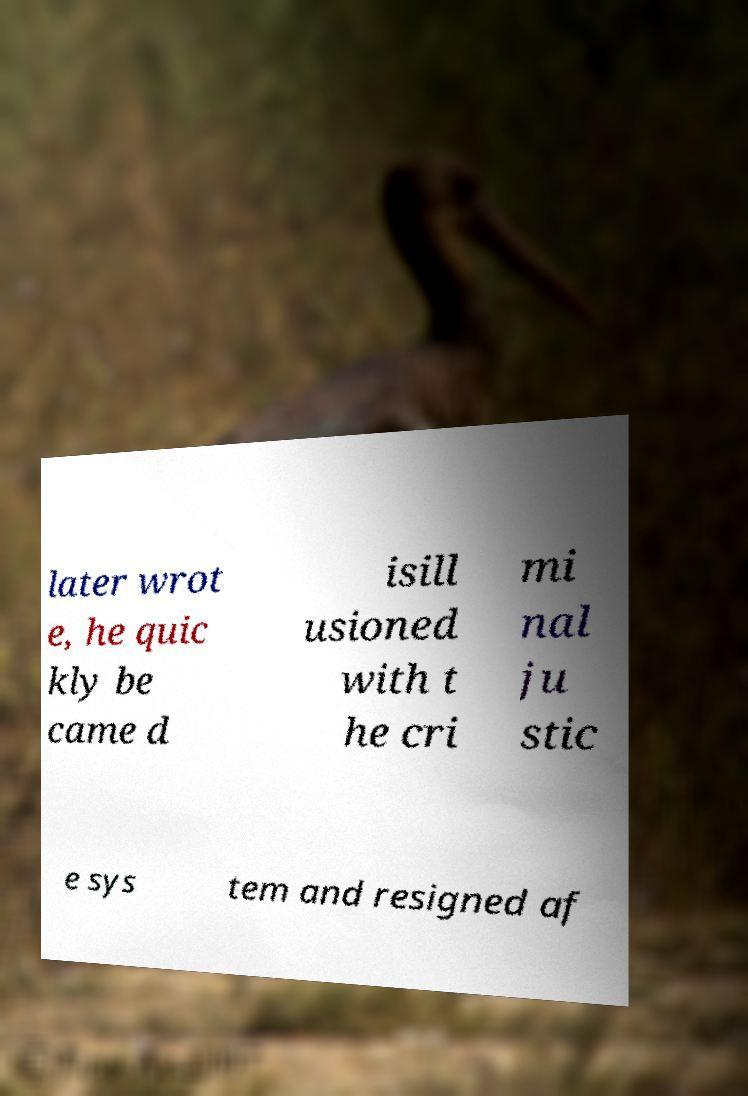There's text embedded in this image that I need extracted. Can you transcribe it verbatim? later wrot e, he quic kly be came d isill usioned with t he cri mi nal ju stic e sys tem and resigned af 